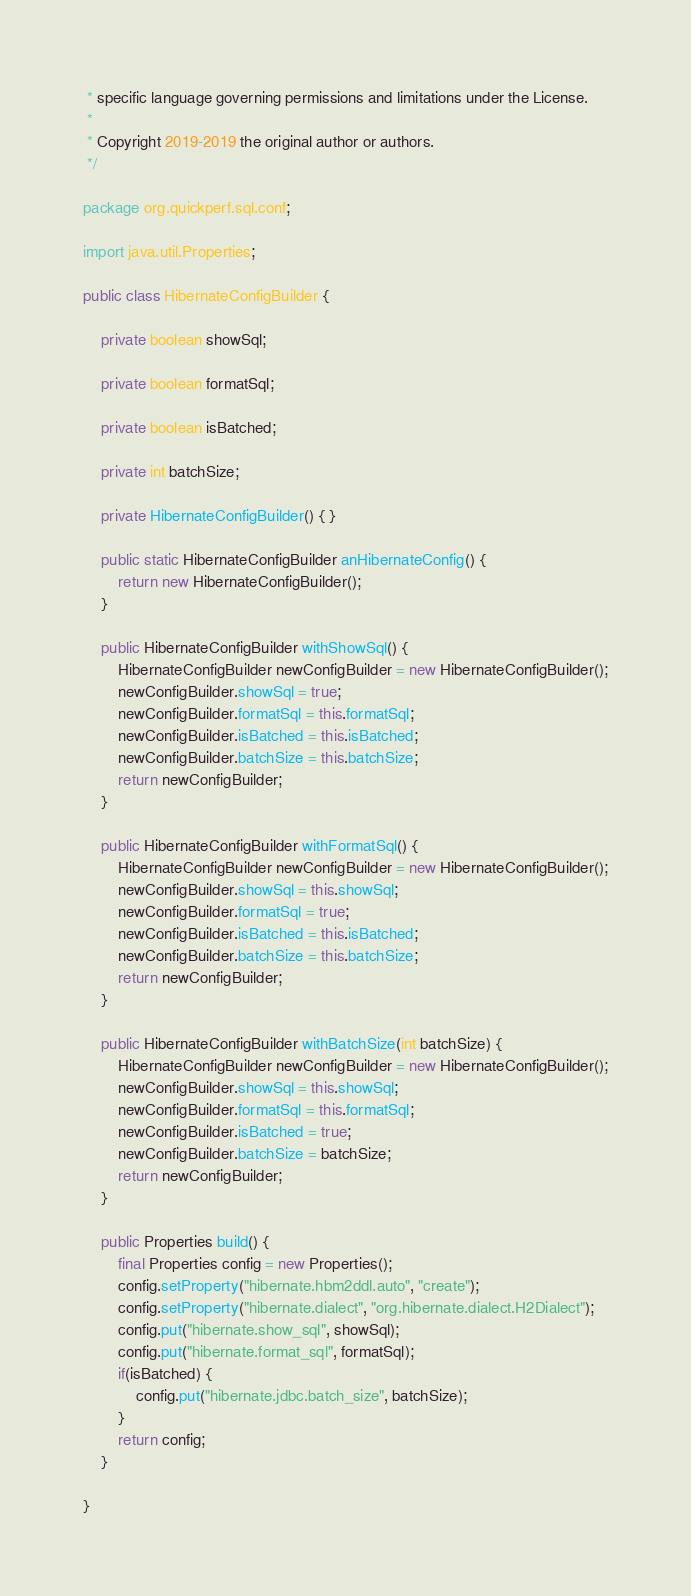Convert code to text. <code><loc_0><loc_0><loc_500><loc_500><_Java_> * specific language governing permissions and limitations under the License.
 *
 * Copyright 2019-2019 the original author or authors.
 */

package org.quickperf.sql.conf;

import java.util.Properties;

public class HibernateConfigBuilder {

    private boolean showSql;

    private boolean formatSql;

    private boolean isBatched;

    private int batchSize;

    private HibernateConfigBuilder() { }

    public static HibernateConfigBuilder anHibernateConfig() {
        return new HibernateConfigBuilder();
    }

    public HibernateConfigBuilder withShowSql() {
        HibernateConfigBuilder newConfigBuilder = new HibernateConfigBuilder();
        newConfigBuilder.showSql = true;
        newConfigBuilder.formatSql = this.formatSql;
        newConfigBuilder.isBatched = this.isBatched;
        newConfigBuilder.batchSize = this.batchSize;
        return newConfigBuilder;
    }

    public HibernateConfigBuilder withFormatSql() {
        HibernateConfigBuilder newConfigBuilder = new HibernateConfigBuilder();
        newConfigBuilder.showSql = this.showSql;
        newConfigBuilder.formatSql = true;
        newConfigBuilder.isBatched = this.isBatched;
        newConfigBuilder.batchSize = this.batchSize;
        return newConfigBuilder;
    }

    public HibernateConfigBuilder withBatchSize(int batchSize) {
        HibernateConfigBuilder newConfigBuilder = new HibernateConfigBuilder();
        newConfigBuilder.showSql = this.showSql;
        newConfigBuilder.formatSql = this.formatSql;
        newConfigBuilder.isBatched = true;
        newConfigBuilder.batchSize = batchSize;
        return newConfigBuilder;
    }

    public Properties build() {
        final Properties config = new Properties();
        config.setProperty("hibernate.hbm2ddl.auto", "create");
        config.setProperty("hibernate.dialect", "org.hibernate.dialect.H2Dialect");
        config.put("hibernate.show_sql", showSql);
        config.put("hibernate.format_sql", formatSql);
        if(isBatched) {
            config.put("hibernate.jdbc.batch_size", batchSize);
        }
        return config;
    }

}
</code> 